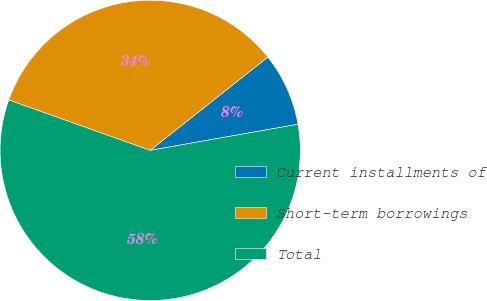Convert chart. <chart><loc_0><loc_0><loc_500><loc_500><pie_chart><fcel>Current installments of<fcel>Short-term borrowings<fcel>Total<nl><fcel>7.89%<fcel>33.88%<fcel>58.22%<nl></chart> 